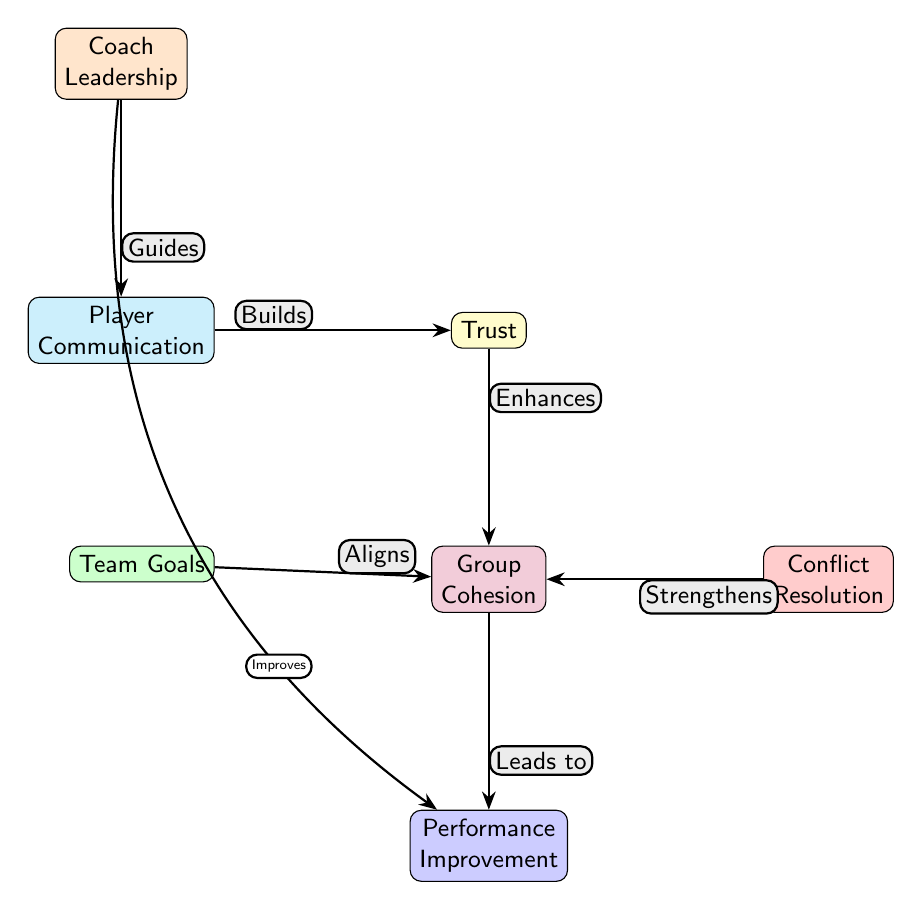What is the starting point of the diagram? The diagram starts with the node labeled "Player Communication," as it is the leftmost node in the visual representation.
Answer: Player Communication How many nodes are present in the diagram? The diagram contains a total of seven nodes: Player Communication, Trust, Coach Leadership, Team Goals, Conflict Resolution, Group Cohesion, and Performance Improvement.
Answer: Seven What relationship does Trust have with Group Cohesion? The diagram shows that Trust "Enhances" Group Cohesion, indicating a positive influence between these two nodes.
Answer: Enhances Which node has a direct connection with Coach Leadership? The node directly connected to Coach Leadership, indicated by an edge, is Player Communication, showing that Coach Leadership guides player communication.
Answer: Player Communication What does Group Cohesion lead to? According to the diagram, Group Cohesion leads to Performance Improvement, indicating that stronger group cohesion promotes better performance outcomes.
Answer: Performance Improvement How does Coach Leadership influence Performance Improvement? The diagram shows that Coach Leadership "Improves" Performance Improvement through its connection, indicating that effective leadership contributes to performance outcomes.
Answer: Improves Which nodes are connected to the Trust node? The Trust node has three connections: it is linked to Player Communication, Group Cohesion, and Team Goals, showing its relationship with these aspects.
Answer: Player Communication, Group Cohesion, Team Goals What effect does Conflict Resolution have on Group Cohesion? The diagram states that Conflict Resolution "Strengthens" Group Cohesion, indicating that effective conflict resolution enhances the cohesion within the team.
Answer: Strengthens What is the flow of influence from Player Communication to Performance Improvement? The flow begins at Player Communication, which builds Trust, leading to enhanced Group Cohesion. This cohesion then leads to Performance Improvement, indicating a pathway of influence.
Answer: Player Communication → Trust → Group Cohesion → Performance Improvement 